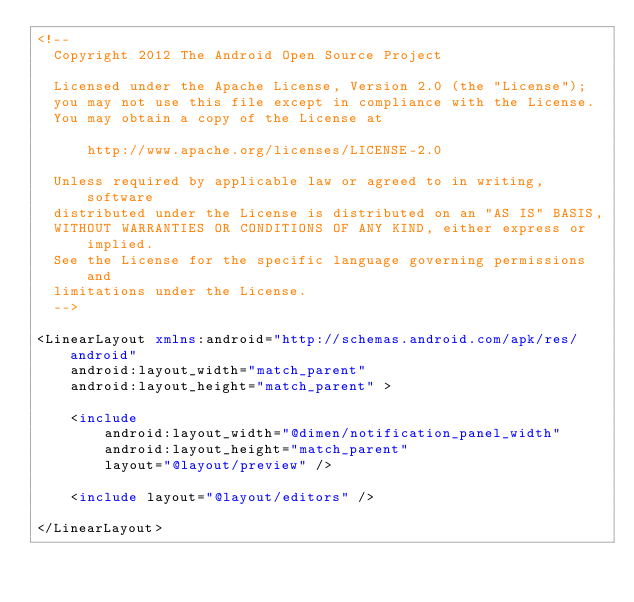Convert code to text. <code><loc_0><loc_0><loc_500><loc_500><_XML_><!--
  Copyright 2012 The Android Open Source Project

  Licensed under the Apache License, Version 2.0 (the "License");
  you may not use this file except in compliance with the License.
  You may obtain a copy of the License at

      http://www.apache.org/licenses/LICENSE-2.0

  Unless required by applicable law or agreed to in writing, software
  distributed under the License is distributed on an "AS IS" BASIS,
  WITHOUT WARRANTIES OR CONDITIONS OF ANY KIND, either express or implied.
  See the License for the specific language governing permissions and
  limitations under the License.
  -->

<LinearLayout xmlns:android="http://schemas.android.com/apk/res/android"
    android:layout_width="match_parent"
    android:layout_height="match_parent" >

    <include
        android:layout_width="@dimen/notification_panel_width"
        android:layout_height="match_parent"
        layout="@layout/preview" />

    <include layout="@layout/editors" />

</LinearLayout></code> 